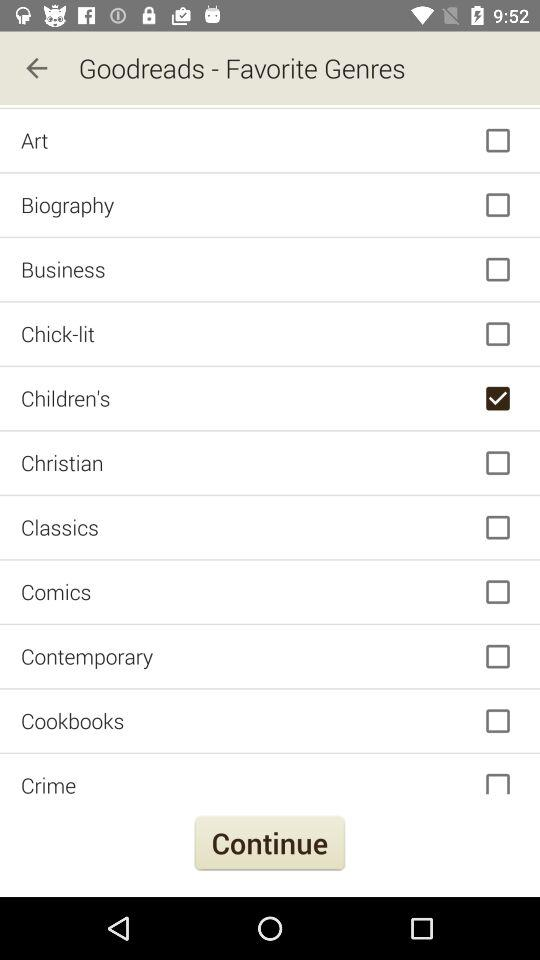What is the current status of crime? The status is off. 